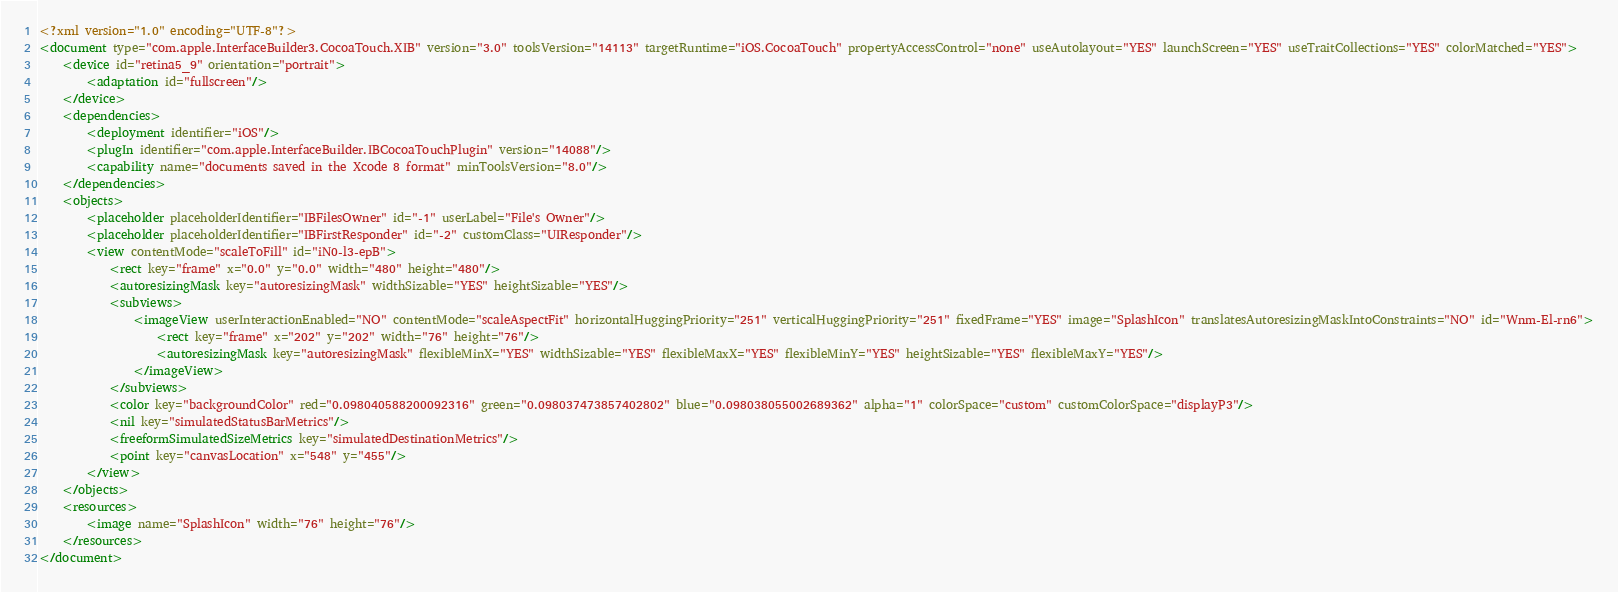<code> <loc_0><loc_0><loc_500><loc_500><_XML_><?xml version="1.0" encoding="UTF-8"?>
<document type="com.apple.InterfaceBuilder3.CocoaTouch.XIB" version="3.0" toolsVersion="14113" targetRuntime="iOS.CocoaTouch" propertyAccessControl="none" useAutolayout="YES" launchScreen="YES" useTraitCollections="YES" colorMatched="YES">
    <device id="retina5_9" orientation="portrait">
        <adaptation id="fullscreen"/>
    </device>
    <dependencies>
        <deployment identifier="iOS"/>
        <plugIn identifier="com.apple.InterfaceBuilder.IBCocoaTouchPlugin" version="14088"/>
        <capability name="documents saved in the Xcode 8 format" minToolsVersion="8.0"/>
    </dependencies>
    <objects>
        <placeholder placeholderIdentifier="IBFilesOwner" id="-1" userLabel="File's Owner"/>
        <placeholder placeholderIdentifier="IBFirstResponder" id="-2" customClass="UIResponder"/>
        <view contentMode="scaleToFill" id="iN0-l3-epB">
            <rect key="frame" x="0.0" y="0.0" width="480" height="480"/>
            <autoresizingMask key="autoresizingMask" widthSizable="YES" heightSizable="YES"/>
            <subviews>
                <imageView userInteractionEnabled="NO" contentMode="scaleAspectFit" horizontalHuggingPriority="251" verticalHuggingPriority="251" fixedFrame="YES" image="SplashIcon" translatesAutoresizingMaskIntoConstraints="NO" id="Wnm-El-rn6">
                    <rect key="frame" x="202" y="202" width="76" height="76"/>
                    <autoresizingMask key="autoresizingMask" flexibleMinX="YES" widthSizable="YES" flexibleMaxX="YES" flexibleMinY="YES" heightSizable="YES" flexibleMaxY="YES"/>
                </imageView>
            </subviews>
            <color key="backgroundColor" red="0.098040588200092316" green="0.098037473857402802" blue="0.098038055002689362" alpha="1" colorSpace="custom" customColorSpace="displayP3"/>
            <nil key="simulatedStatusBarMetrics"/>
            <freeformSimulatedSizeMetrics key="simulatedDestinationMetrics"/>
            <point key="canvasLocation" x="548" y="455"/>
        </view>
    </objects>
    <resources>
        <image name="SplashIcon" width="76" height="76"/>
    </resources>
</document>
</code> 